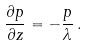Convert formula to latex. <formula><loc_0><loc_0><loc_500><loc_500>\frac { \partial p } { \partial z } = - \frac { p } { \lambda } \, .</formula> 